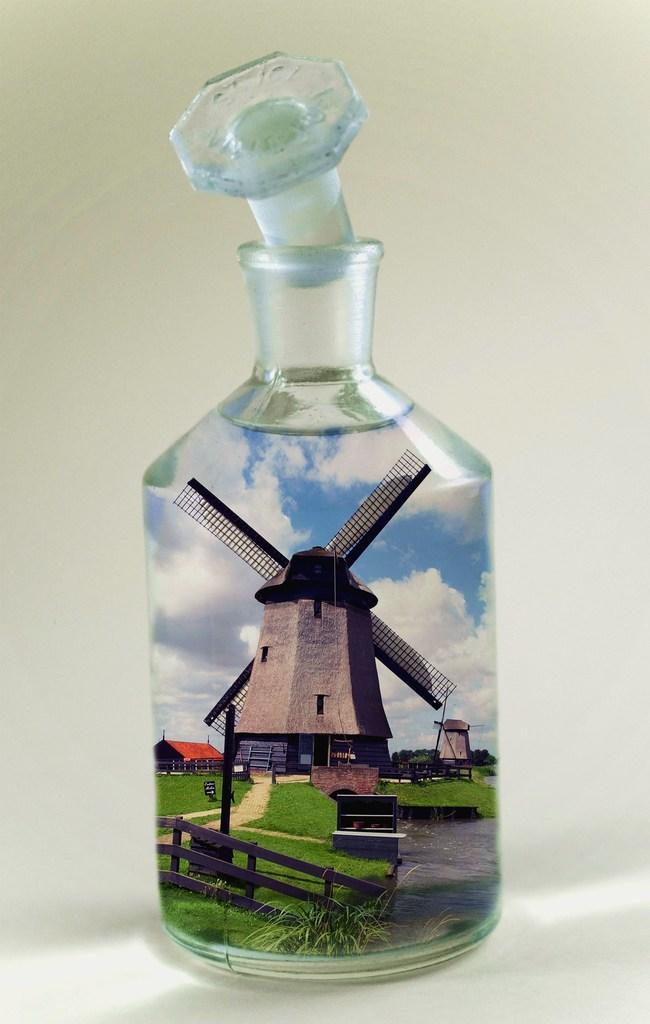Could you give a brief overview of what you see in this image? In this image we can see a glass bottle in which we can see a windmill, wooden fence, house, clouds and sky. This is the lid. 